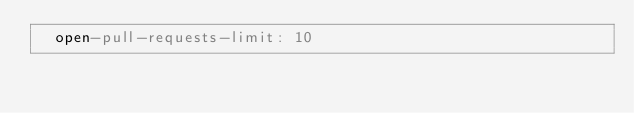Convert code to text. <code><loc_0><loc_0><loc_500><loc_500><_YAML_>  open-pull-requests-limit: 10
</code> 